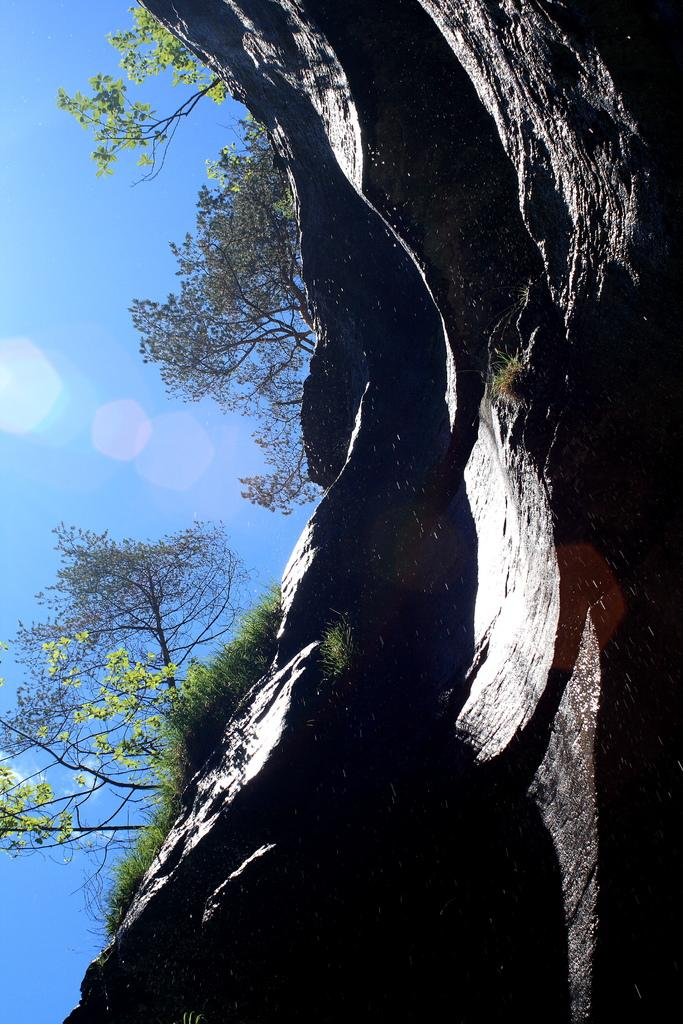What type of natural formation can be seen in the image? There is a mountain in the image. What type of vegetation is present in the image? There is grass and trees in the image. What part of the natural environment is visible in the background of the image? The sky is visible in the background of the image. Where is the dock located in the image? There is no dock present in the image. What type of tool is used to cut the grass in the image? There is no tool or activity of cutting grass depicted in the image. 